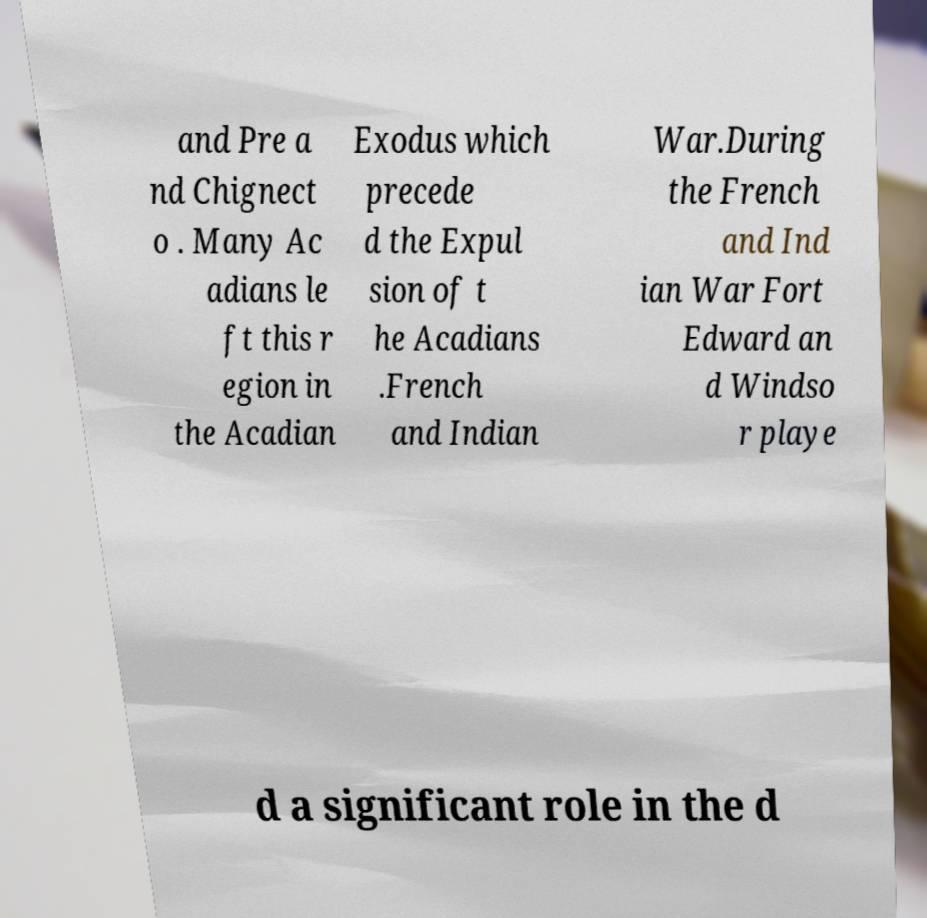Could you extract and type out the text from this image? and Pre a nd Chignect o . Many Ac adians le ft this r egion in the Acadian Exodus which precede d the Expul sion of t he Acadians .French and Indian War.During the French and Ind ian War Fort Edward an d Windso r playe d a significant role in the d 